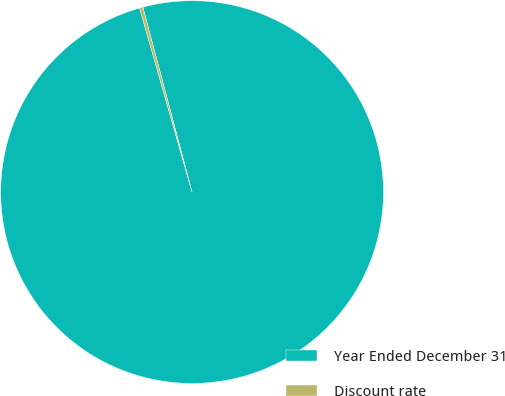<chart> <loc_0><loc_0><loc_500><loc_500><pie_chart><fcel>Year Ended December 31<fcel>Discount rate<nl><fcel>99.72%<fcel>0.28%<nl></chart> 